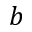Convert formula to latex. <formula><loc_0><loc_0><loc_500><loc_500>b</formula> 